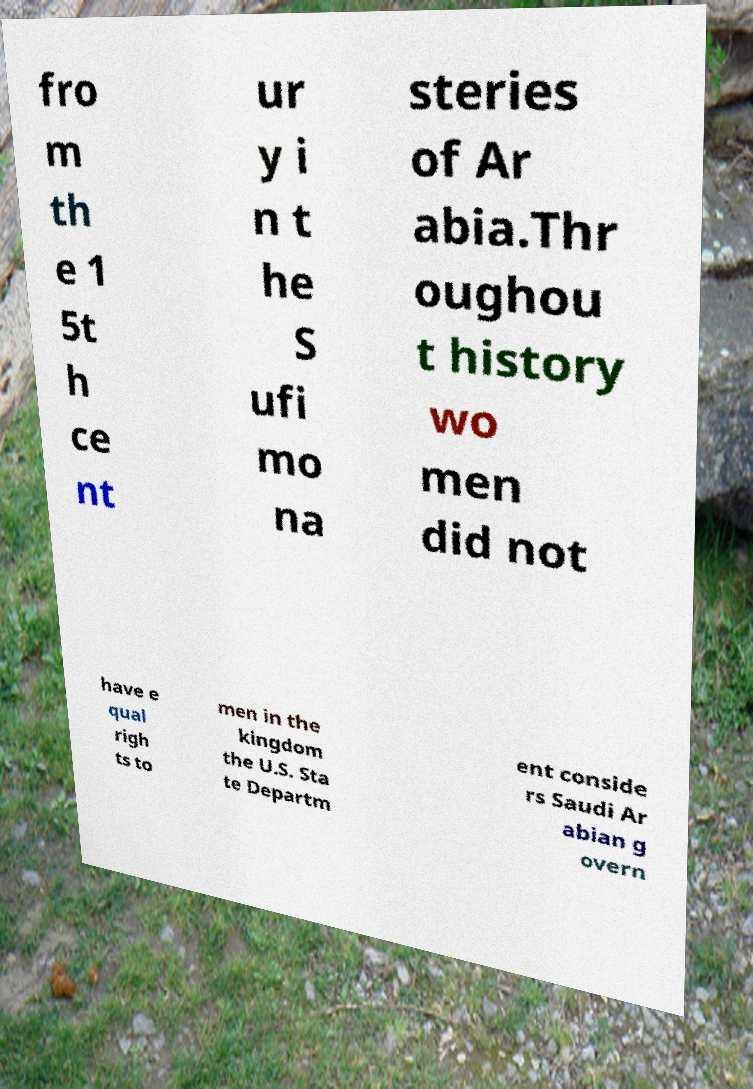Can you accurately transcribe the text from the provided image for me? fro m th e 1 5t h ce nt ur y i n t he S ufi mo na steries of Ar abia.Thr oughou t history wo men did not have e qual righ ts to men in the kingdom the U.S. Sta te Departm ent conside rs Saudi Ar abian g overn 